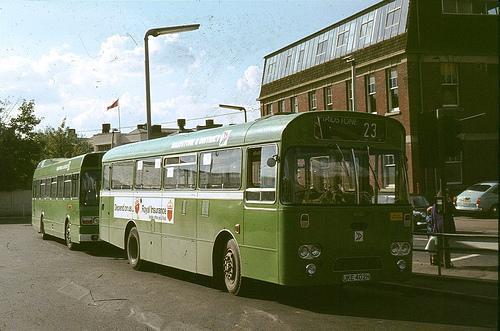How many buses are shown?
Give a very brief answer. 2. How many green buses can you see?
Give a very brief answer. 2. 